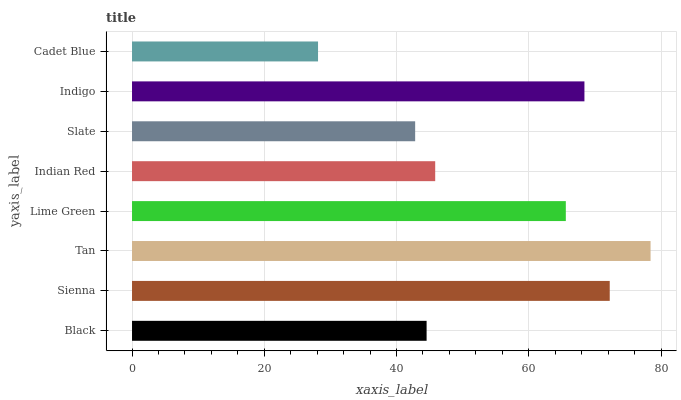Is Cadet Blue the minimum?
Answer yes or no. Yes. Is Tan the maximum?
Answer yes or no. Yes. Is Sienna the minimum?
Answer yes or no. No. Is Sienna the maximum?
Answer yes or no. No. Is Sienna greater than Black?
Answer yes or no. Yes. Is Black less than Sienna?
Answer yes or no. Yes. Is Black greater than Sienna?
Answer yes or no. No. Is Sienna less than Black?
Answer yes or no. No. Is Lime Green the high median?
Answer yes or no. Yes. Is Indian Red the low median?
Answer yes or no. Yes. Is Indian Red the high median?
Answer yes or no. No. Is Tan the low median?
Answer yes or no. No. 